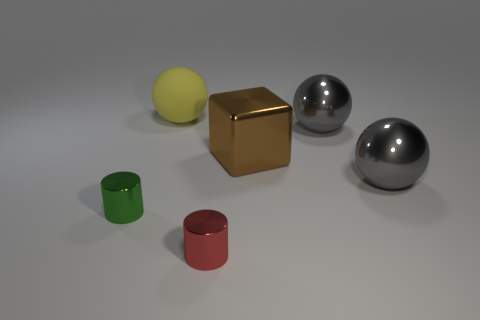What color is the object that is the same size as the green cylinder?
Keep it short and to the point. Red. How many matte things are cyan things or large brown cubes?
Your response must be concise. 0. Is the number of tiny yellow blocks the same as the number of small cylinders?
Your answer should be very brief. No. How many objects are behind the tiny green cylinder and to the right of the large yellow rubber ball?
Your answer should be very brief. 3. Are there any other things that are the same shape as the red shiny thing?
Keep it short and to the point. Yes. How many other objects are the same size as the yellow object?
Your answer should be very brief. 3. There is a ball that is on the left side of the small red cylinder; is it the same size as the cylinder on the right side of the large yellow matte thing?
Your answer should be very brief. No. What number of things are either green metal cylinders or big balls left of the large metallic cube?
Provide a succinct answer. 2. There is a cube behind the tiny green metal cylinder; how big is it?
Provide a succinct answer. Large. Are there fewer gray metal things that are to the left of the large yellow thing than large yellow matte objects that are on the left side of the red metal cylinder?
Keep it short and to the point. Yes. 